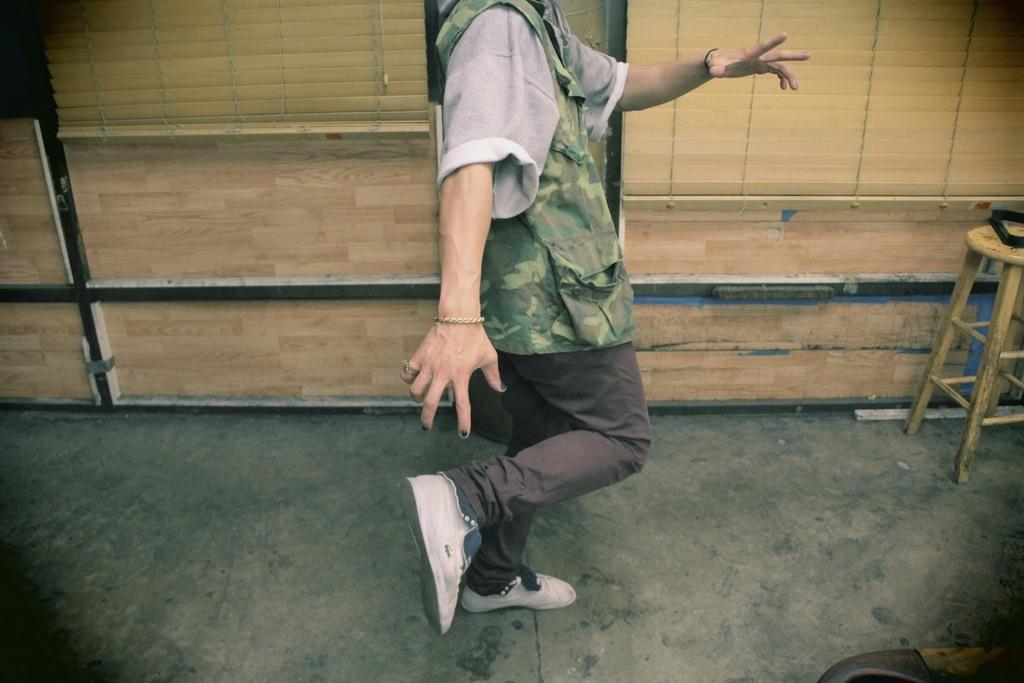What is the main subject in the image? There is a person standing in the image. What can be seen behind the person? There is a wall behind the person. What piece of furniture is on the right side of the image? There is a chair on the right side of the image. What type of lift is present in the image? There is no lift present in the image. How many units are visible in the image? The image does not show any units or measurements, so it is not possible to determine the number of units. 